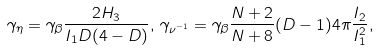Convert formula to latex. <formula><loc_0><loc_0><loc_500><loc_500>\gamma _ { \eta } = \gamma _ { \beta } \frac { 2 H _ { 3 } } { I _ { 1 } D ( 4 - D ) } , \, \gamma _ { \nu ^ { - 1 } } = \gamma _ { \beta } \frac { N + 2 } { N + 8 } ( D - 1 ) 4 \pi \frac { I _ { 2 } } { I _ { 1 } ^ { 2 } } ,</formula> 